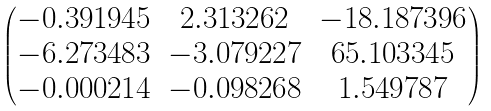<formula> <loc_0><loc_0><loc_500><loc_500>\begin{pmatrix} - 0 . 3 9 1 9 4 5 & 2 . 3 1 3 2 6 2 & - 1 8 . 1 8 7 3 9 6 \\ - 6 . 2 7 3 4 8 3 & - 3 . 0 7 9 2 2 7 & 6 5 . 1 0 3 3 4 5 \\ - 0 . 0 0 0 2 1 4 & - 0 . 0 9 8 2 6 8 & 1 . 5 4 9 7 8 7 \end{pmatrix}</formula> 